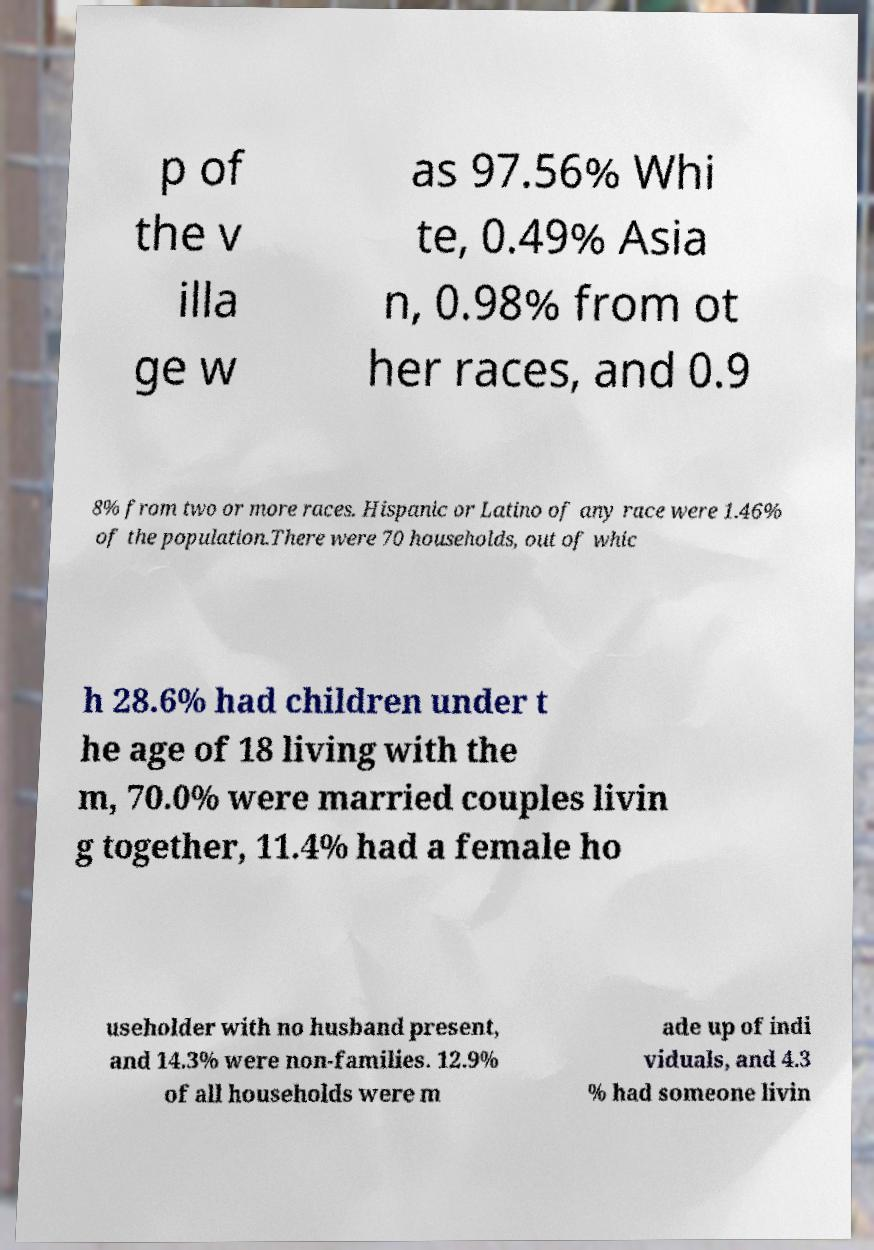I need the written content from this picture converted into text. Can you do that? p of the v illa ge w as 97.56% Whi te, 0.49% Asia n, 0.98% from ot her races, and 0.9 8% from two or more races. Hispanic or Latino of any race were 1.46% of the population.There were 70 households, out of whic h 28.6% had children under t he age of 18 living with the m, 70.0% were married couples livin g together, 11.4% had a female ho useholder with no husband present, and 14.3% were non-families. 12.9% of all households were m ade up of indi viduals, and 4.3 % had someone livin 